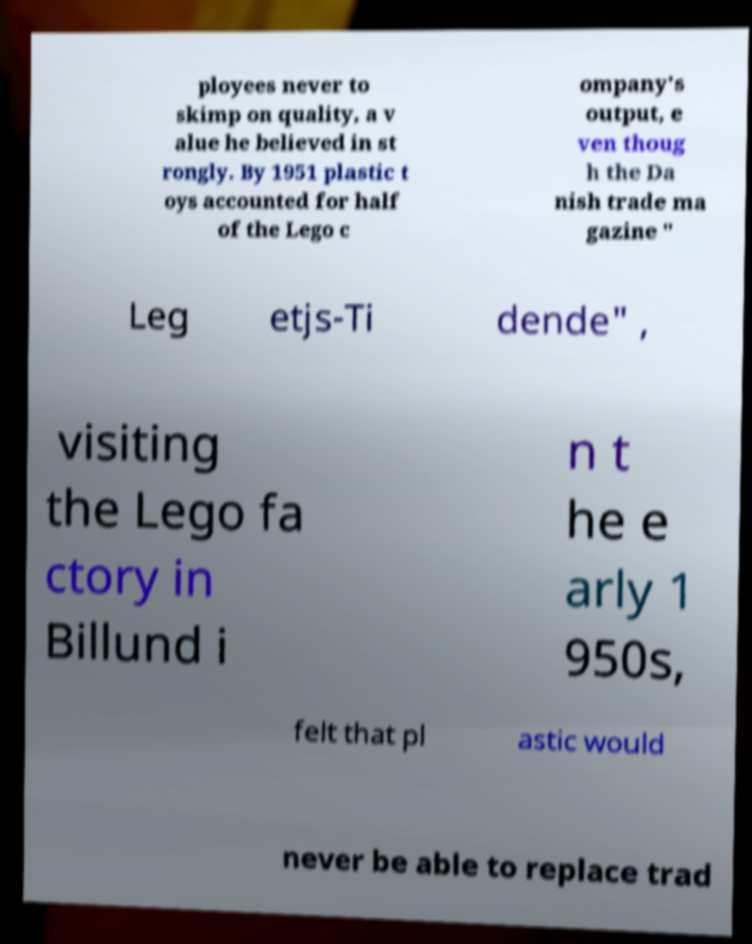There's text embedded in this image that I need extracted. Can you transcribe it verbatim? ployees never to skimp on quality, a v alue he believed in st rongly. By 1951 plastic t oys accounted for half of the Lego c ompany's output, e ven thoug h the Da nish trade ma gazine " Leg etjs-Ti dende" , visiting the Lego fa ctory in Billund i n t he e arly 1 950s, felt that pl astic would never be able to replace trad 